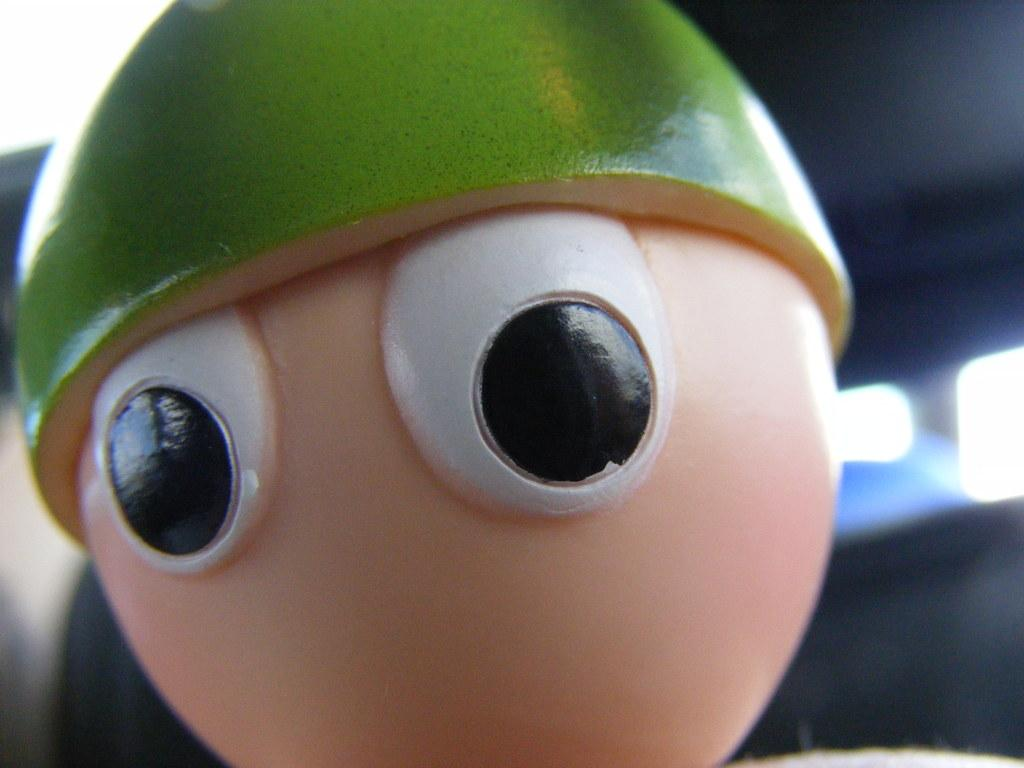What object can be seen in the image? There is a toy in the image. What can be seen in the background of the image? There are lights and a wall visible in the background of the image. What news is being reported on the toy in the image? There is no news being reported on the toy in the image, as it is a toy and not a source of news. 